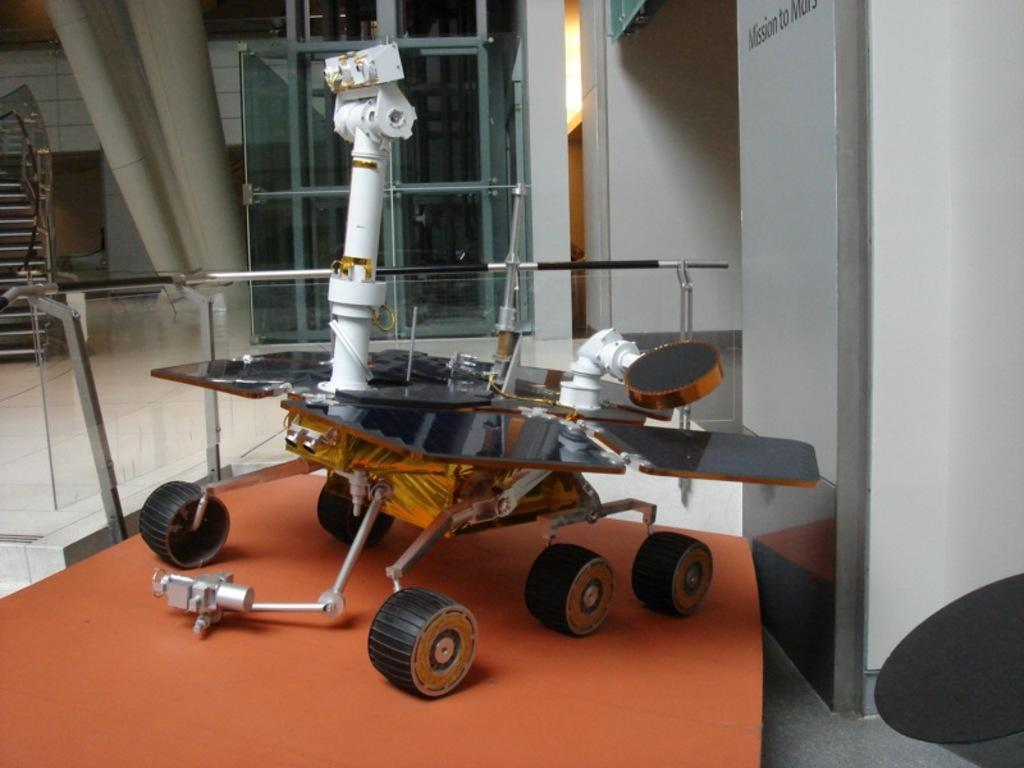What is the main subject of the image? The main subject of the image is a robotic machine. Can you describe the background of the image? There is a glass wall in the background of the image. How many rails can be seen in the image? There are no rails present in the image. What type of head is attached to the robotic machine in the image? The image does not show a head attached to the robotic machine, as it is a machine and not a living being. 